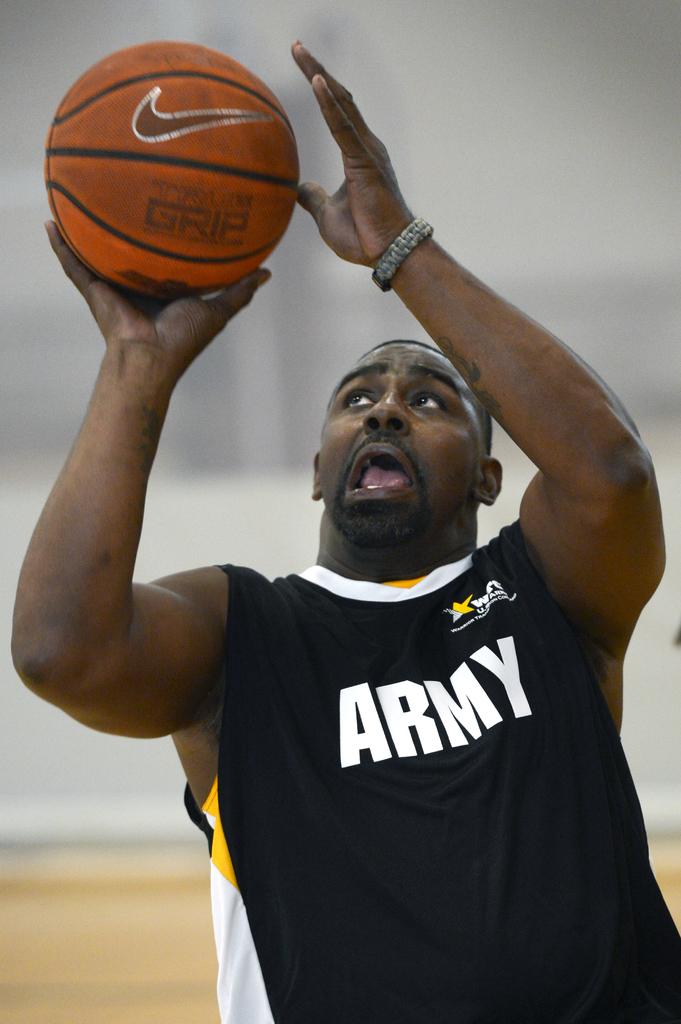What military branch does the man's jersey represent?
Make the answer very short. Army. Does that basketball claim to have grip?
Offer a very short reply. Yes. 